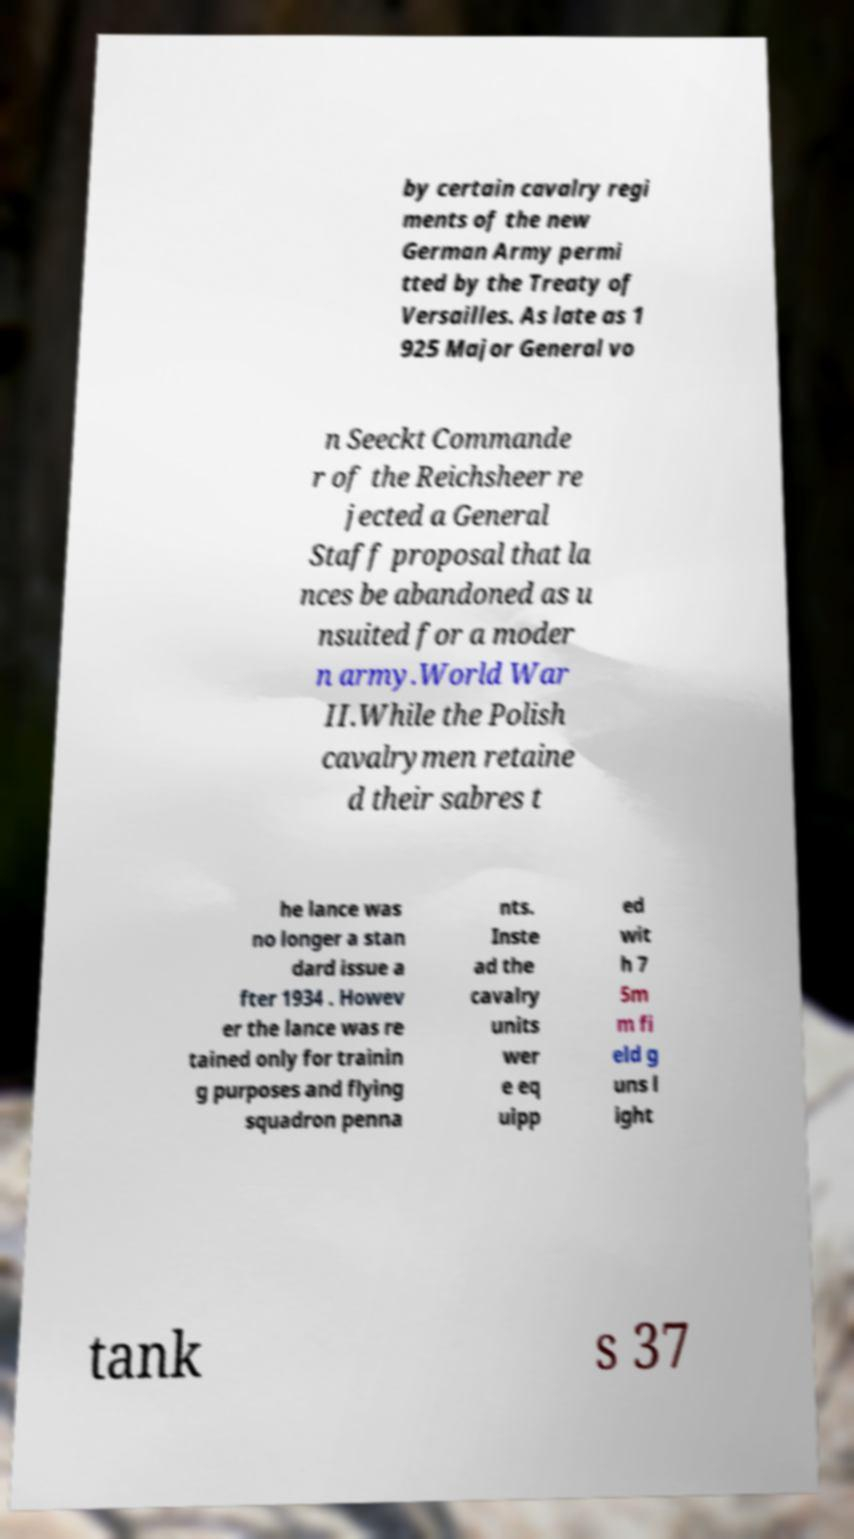Could you extract and type out the text from this image? by certain cavalry regi ments of the new German Army permi tted by the Treaty of Versailles. As late as 1 925 Major General vo n Seeckt Commande r of the Reichsheer re jected a General Staff proposal that la nces be abandoned as u nsuited for a moder n army.World War II.While the Polish cavalrymen retaine d their sabres t he lance was no longer a stan dard issue a fter 1934 . Howev er the lance was re tained only for trainin g purposes and flying squadron penna nts. Inste ad the cavalry units wer e eq uipp ed wit h 7 5m m fi eld g uns l ight tank s 37 